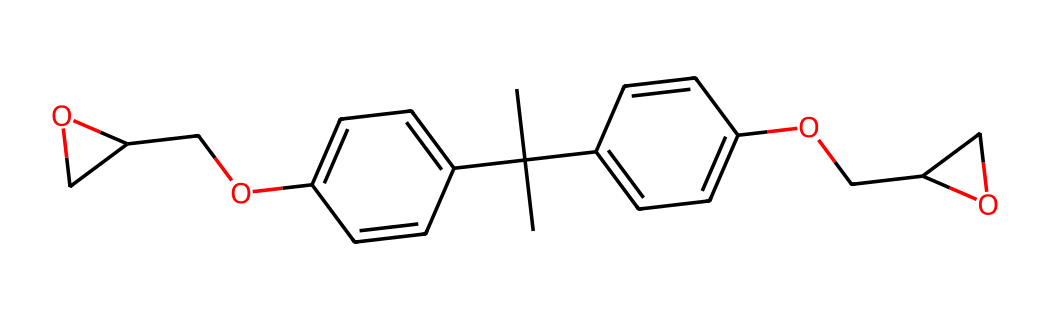What is the molecular formula of this chemical? To determine the molecular formula, you need to count the number of each type of atom present in the SMILES representation. After analysis, the components can be counted, yielding a formula that encompasses the counts of carbon (C), hydrogen (H), and oxygen (O) in the structure.
Answer: C19H28O4 How many rings are present in the structure? By examining the SMILES representation, we can identify rings by looking for the consecutive numbers that indicate where a ring starts and ends. In this case, we find two distinct number pairs indicating two ring closures.
Answer: 2 What functional group is represented by the hydroxyl group in this molecule? The hydroxyl group (-OH) can be identified in the structure; it is responsible for creating alcohol functionality. The presence of this group is crucial for understanding its reactivity and compatibility with other materials.
Answer: alcohol Which element appears as part of the structure and is essential for the epoxy function? The epoxy function is characterized by an ether bond between carbon atoms (having an oxygen) generally found in the form of an epoxide in the structure. The presence of the oxygen atom is essential for forming polyfunctional connections in epoxy resins.
Answer: oxygen What is the significance of the bulky tert-butyl group in this resin? The tert-butyl group is a large substituent that can enhance the stability and rigidity of the polymer formed from this monomer. Its large size prevents closer packing and allows for better flow properties, improving the performance of the final resin product.
Answer: stability 